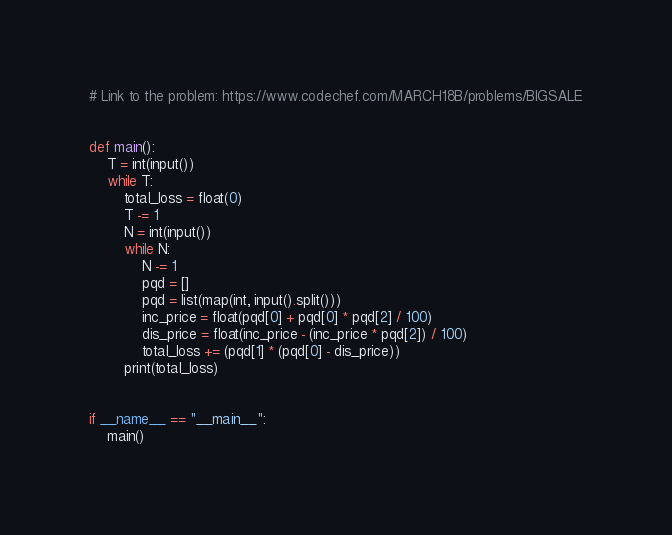<code> <loc_0><loc_0><loc_500><loc_500><_Python_># Link to the problem: https://www.codechef.com/MARCH18B/problems/BIGSALE


def main():
    T = int(input())
    while T:
        total_loss = float(0)
        T -= 1
        N = int(input())
        while N:
            N -= 1
            pqd = []
            pqd = list(map(int, input().split()))
            inc_price = float(pqd[0] + pqd[0] * pqd[2] / 100)
            dis_price = float(inc_price - (inc_price * pqd[2]) / 100)
            total_loss += (pqd[1] * (pqd[0] - dis_price))
        print(total_loss)


if __name__ == "__main__":
    main()
</code> 